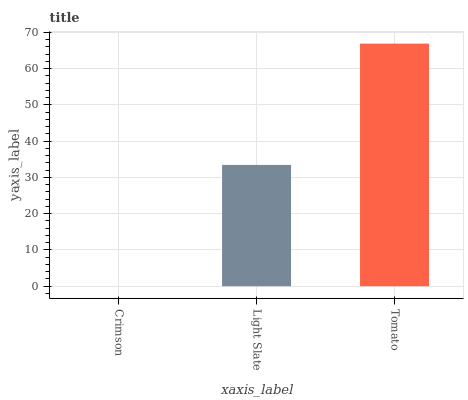Is Crimson the minimum?
Answer yes or no. Yes. Is Tomato the maximum?
Answer yes or no. Yes. Is Light Slate the minimum?
Answer yes or no. No. Is Light Slate the maximum?
Answer yes or no. No. Is Light Slate greater than Crimson?
Answer yes or no. Yes. Is Crimson less than Light Slate?
Answer yes or no. Yes. Is Crimson greater than Light Slate?
Answer yes or no. No. Is Light Slate less than Crimson?
Answer yes or no. No. Is Light Slate the high median?
Answer yes or no. Yes. Is Light Slate the low median?
Answer yes or no. Yes. Is Tomato the high median?
Answer yes or no. No. Is Tomato the low median?
Answer yes or no. No. 